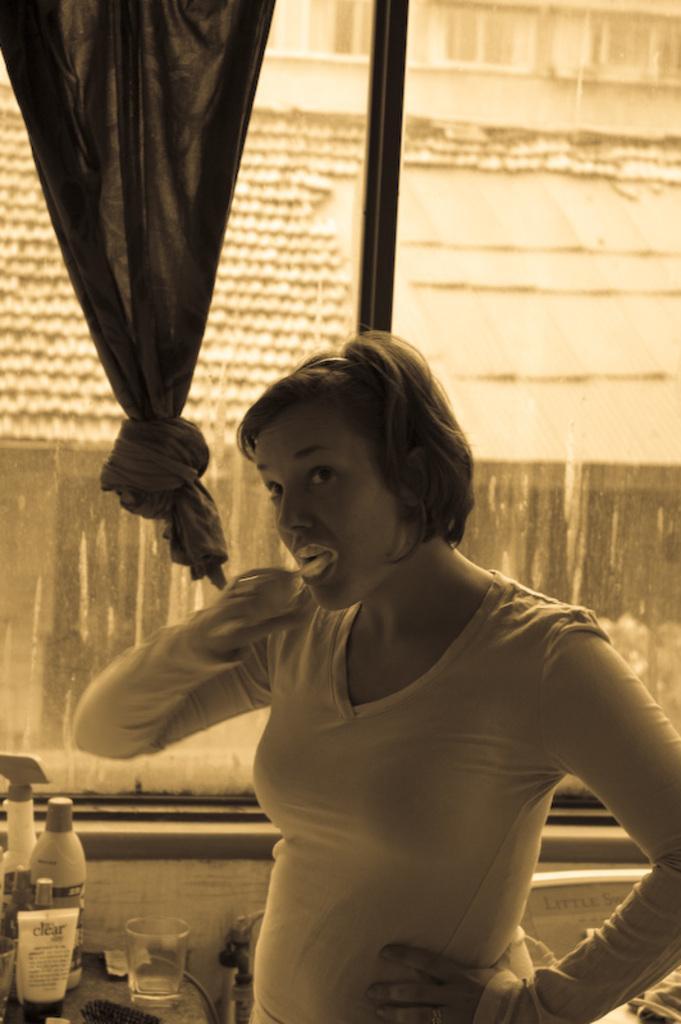Can you describe this image briefly? In this image I can see a woman is standing. In the background I can see a bottle, a glass, curtain, window, building and here I can see few other stuffs. I can also see this image is little bit in brown colour. 